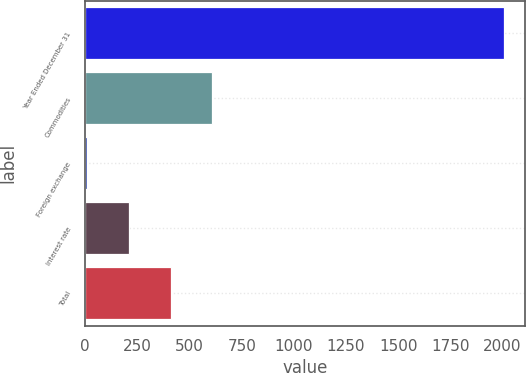<chart> <loc_0><loc_0><loc_500><loc_500><bar_chart><fcel>Year Ended December 31<fcel>Commodities<fcel>Foreign exchange<fcel>Interest rate<fcel>Total<nl><fcel>2009<fcel>609.7<fcel>10<fcel>209.9<fcel>409.8<nl></chart> 